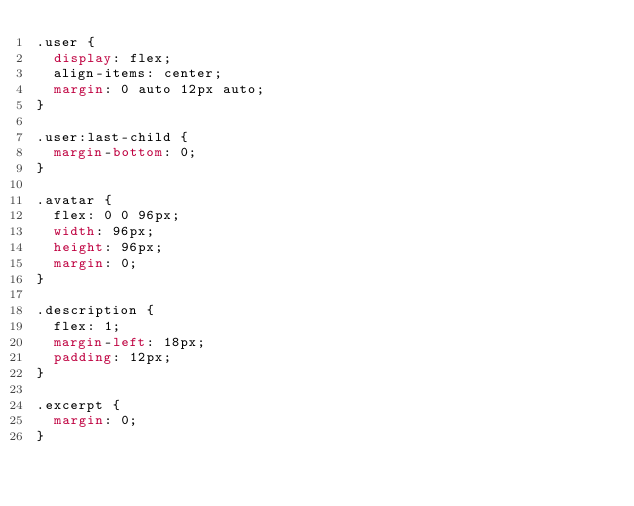Convert code to text. <code><loc_0><loc_0><loc_500><loc_500><_CSS_>.user {
  display: flex;
  align-items: center;
  margin: 0 auto 12px auto;
}

.user:last-child {
  margin-bottom: 0;
}

.avatar {
  flex: 0 0 96px;
  width: 96px;
  height: 96px;
  margin: 0;
}

.description {
  flex: 1;
  margin-left: 18px;
  padding: 12px;
}

.excerpt {
  margin: 0;
}
</code> 